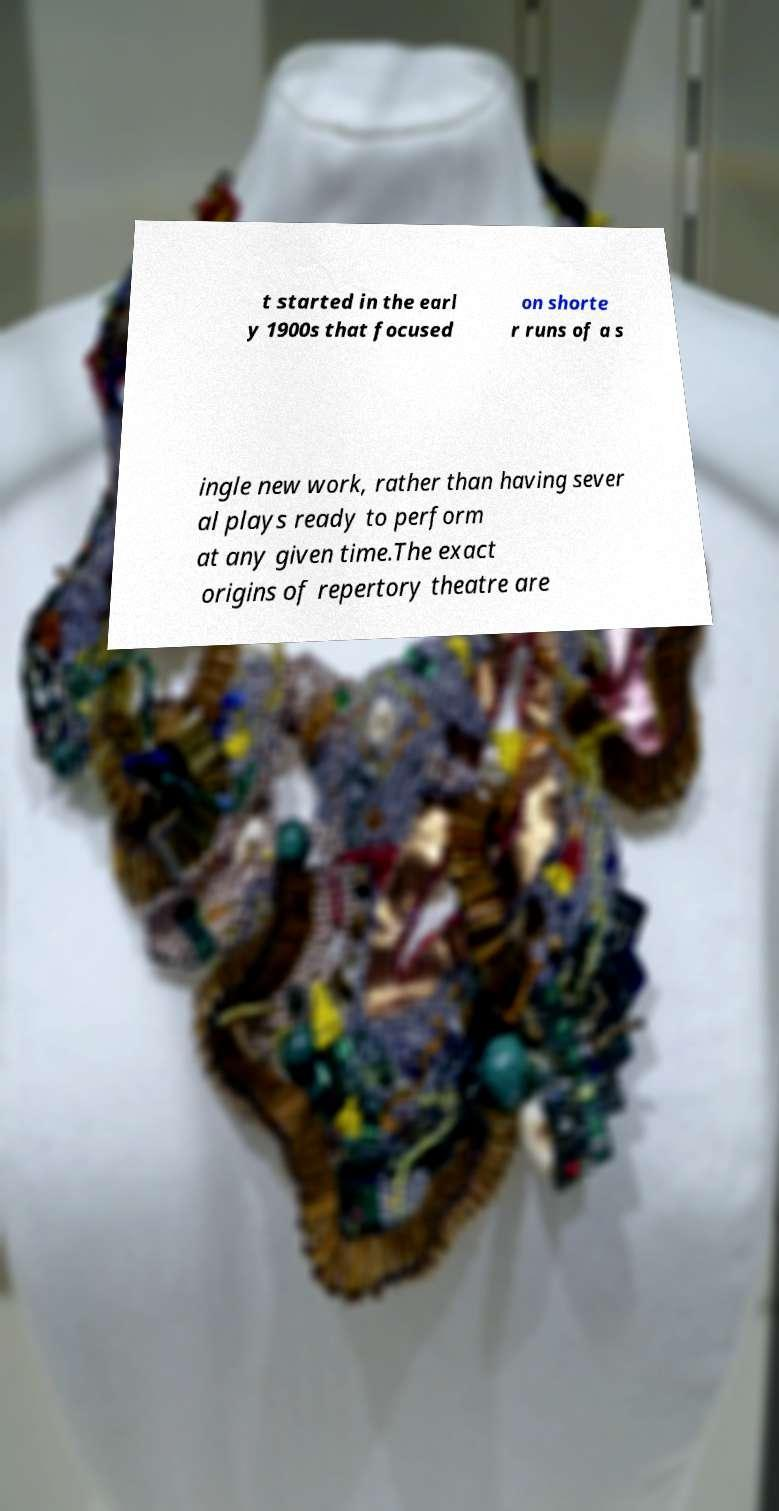Please identify and transcribe the text found in this image. t started in the earl y 1900s that focused on shorte r runs of a s ingle new work, rather than having sever al plays ready to perform at any given time.The exact origins of repertory theatre are 